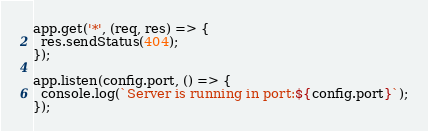<code> <loc_0><loc_0><loc_500><loc_500><_JavaScript_>app.get('*', (req, res) => {
  res.sendStatus(404);
});

app.listen(config.port, () => {
  console.log(`Server is running in port:${config.port}`);
});
</code> 